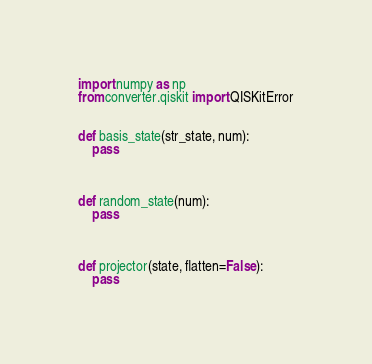<code> <loc_0><loc_0><loc_500><loc_500><_Python_>





import numpy as np
from converter.qiskit import QISKitError


def basis_state(str_state, num):
    pass



def random_state(num):
    pass



def projector(state, flatten=False):
    pass

</code> 